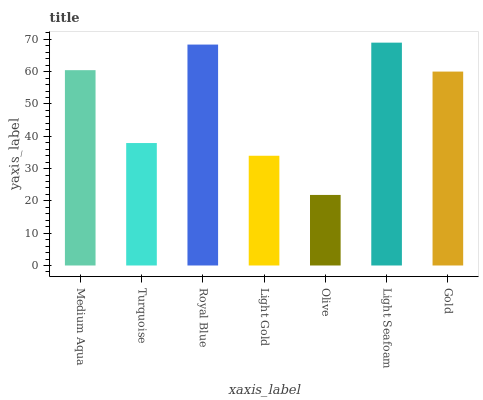Is Olive the minimum?
Answer yes or no. Yes. Is Light Seafoam the maximum?
Answer yes or no. Yes. Is Turquoise the minimum?
Answer yes or no. No. Is Turquoise the maximum?
Answer yes or no. No. Is Medium Aqua greater than Turquoise?
Answer yes or no. Yes. Is Turquoise less than Medium Aqua?
Answer yes or no. Yes. Is Turquoise greater than Medium Aqua?
Answer yes or no. No. Is Medium Aqua less than Turquoise?
Answer yes or no. No. Is Gold the high median?
Answer yes or no. Yes. Is Gold the low median?
Answer yes or no. Yes. Is Turquoise the high median?
Answer yes or no. No. Is Olive the low median?
Answer yes or no. No. 